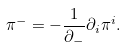Convert formula to latex. <formula><loc_0><loc_0><loc_500><loc_500>{ \pi } ^ { - } = - \frac { 1 } { { \partial } _ { - } } { \partial } _ { i } { \pi } ^ { i } .</formula> 